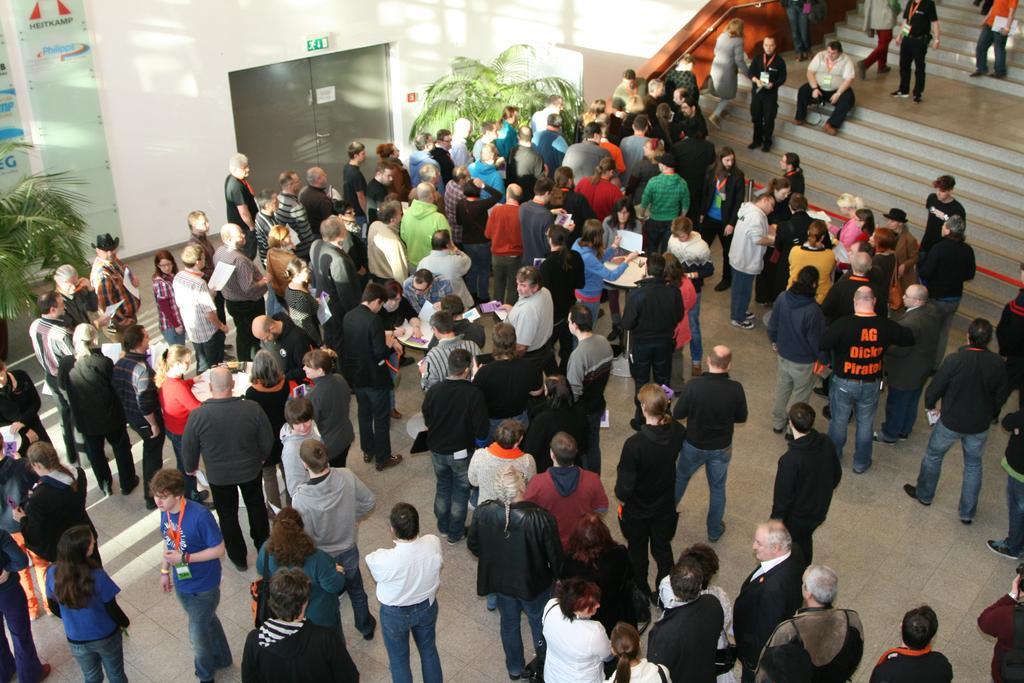Describe this image in one or two sentences. In the center of the image there are many people standing. There are staircases. There are plants. There is a lift in the background of the image. 